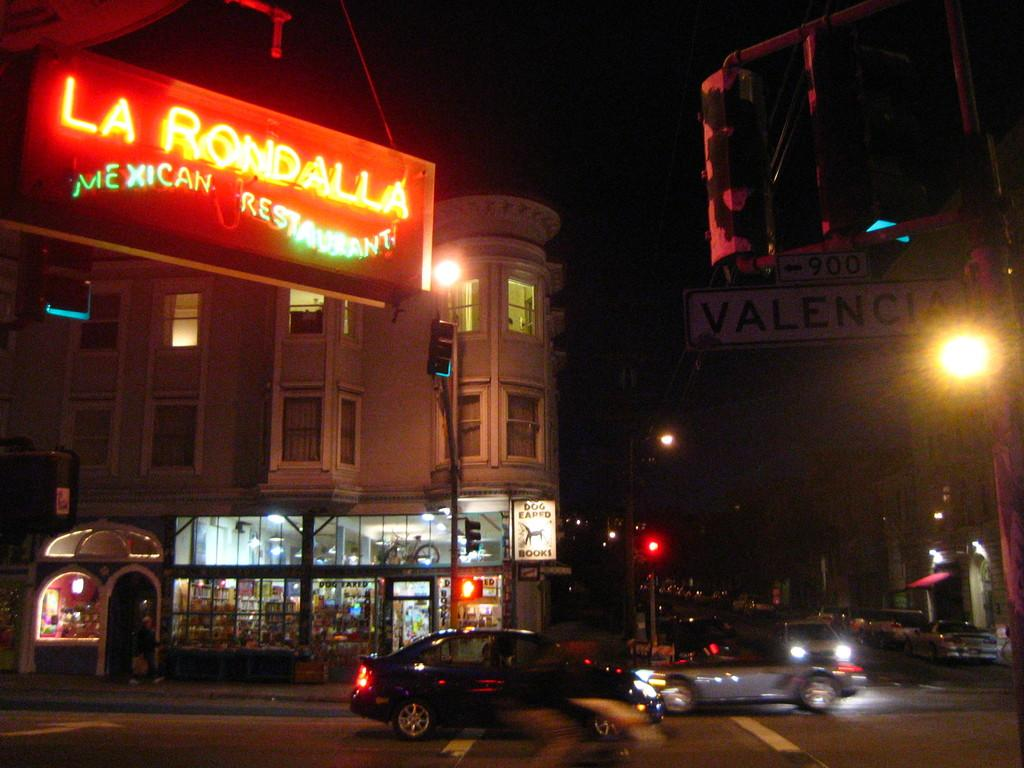What is the lighting condition in the image? The image is taken in the dark. What electronic device is present in the image? There is an LED board in the image. What is happening on the road in the image? Vehicles are moving on the road in the image. What structure is present near the road in the image? There is a traffic signal pole in the image. What other type of pole is present in the image? There is a light pole in the image. What type of man-made structures can be seen in the image? There are buildings in the image. What is the color of the sky in the background of the image? The sky in the background is dark. Can you see any animals fighting on the farm in the image? There is no farm or fighting animals present in the image. What type of bed is visible in the image? There is no bed present in the image. 